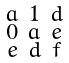<formula> <loc_0><loc_0><loc_500><loc_500>\begin{smallmatrix} a & 1 & d \\ 0 & a & e \\ e & d & f \end{smallmatrix}</formula> 